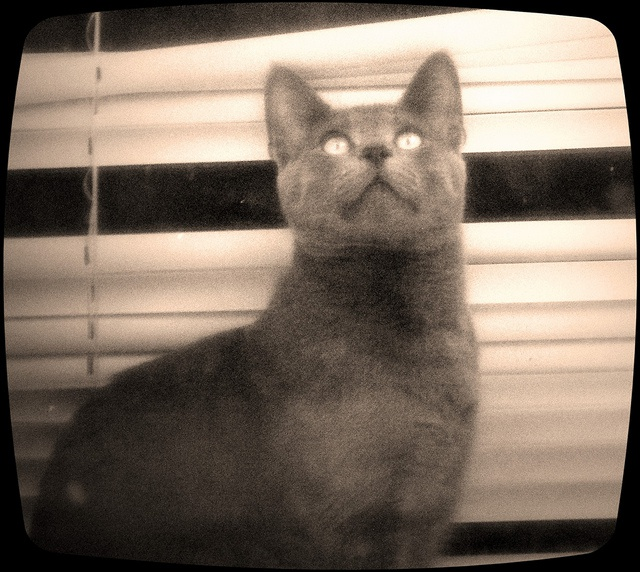Describe the objects in this image and their specific colors. I can see a cat in black and gray tones in this image. 